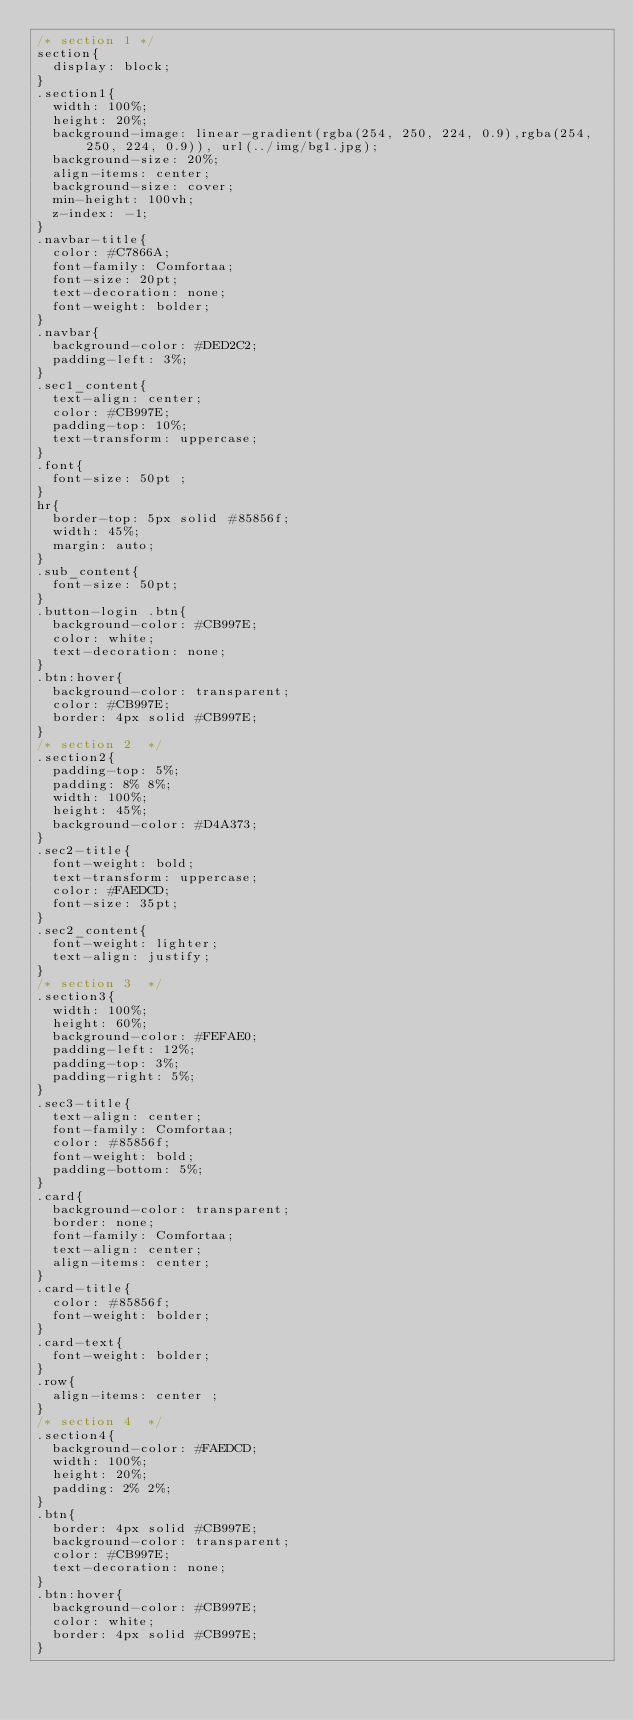Convert code to text. <code><loc_0><loc_0><loc_500><loc_500><_CSS_>/* section 1 */
section{
  display: block;
}
.section1{
  width: 100%;
  height: 20%;
  background-image: linear-gradient(rgba(254, 250, 224, 0.9),rgba(254, 250, 224, 0.9)), url(../img/bg1.jpg);
  background-size: 20%;
  align-items: center;
  background-size: cover;
  min-height: 100vh;
  z-index: -1;
}
.navbar-title{
  color: #C7866A;
  font-family: Comfortaa;
  font-size: 20pt;
  text-decoration: none;
  font-weight: bolder;
}
.navbar{
  background-color: #DED2C2;
  padding-left: 3%;
}
.sec1_content{
  text-align: center;
  color: #CB997E;
  padding-top: 10%;
  text-transform: uppercase;
}
.font{
  font-size: 50pt ;
}
hr{
  border-top: 5px solid #85856f;
  width: 45%;
  margin: auto;
}
.sub_content{
  font-size: 50pt;
}
.button-login .btn{
  background-color: #CB997E;  
  color: white;
  text-decoration: none;
}
.btn:hover{
  background-color: transparent;
  color: #CB997E;
  border: 4px solid #CB997E;
}
/* section 2  */
.section2{
  padding-top: 5%;
  padding: 8% 8%;
  width: 100%;
  height: 45%;
  background-color: #D4A373;
}
.sec2-title{
  font-weight: bold;
  text-transform: uppercase;
  color: #FAEDCD;
  font-size: 35pt;
}
.sec2_content{
  font-weight: lighter;
  text-align: justify;
}
/* section 3  */
.section3{
  width: 100%;
  height: 60%;
  background-color: #FEFAE0;
  padding-left: 12%;
  padding-top: 3%;
  padding-right: 5%;
}
.sec3-title{
  text-align: center;
  font-family: Comfortaa;
  color: #85856f;
  font-weight: bold;
  padding-bottom: 5%;
}
.card{
  background-color: transparent;
  border: none;
  font-family: Comfortaa;
  text-align: center;
  align-items: center;
}
.card-title{
  color: #85856f;
  font-weight: bolder;
}
.card-text{
  font-weight: bolder;
}
.row{
  align-items: center ;
}
/* section 4  */
.section4{
  background-color: #FAEDCD;
  width: 100%;
  height: 20%;
  padding: 2% 2%;
}
.btn{
  border: 4px solid #CB997E;
  background-color: transparent;
  color: #CB997E;
  text-decoration: none;
}
.btn:hover{
  background-color: #CB997E;
  color: white;
  border: 4px solid #CB997E;
}

</code> 